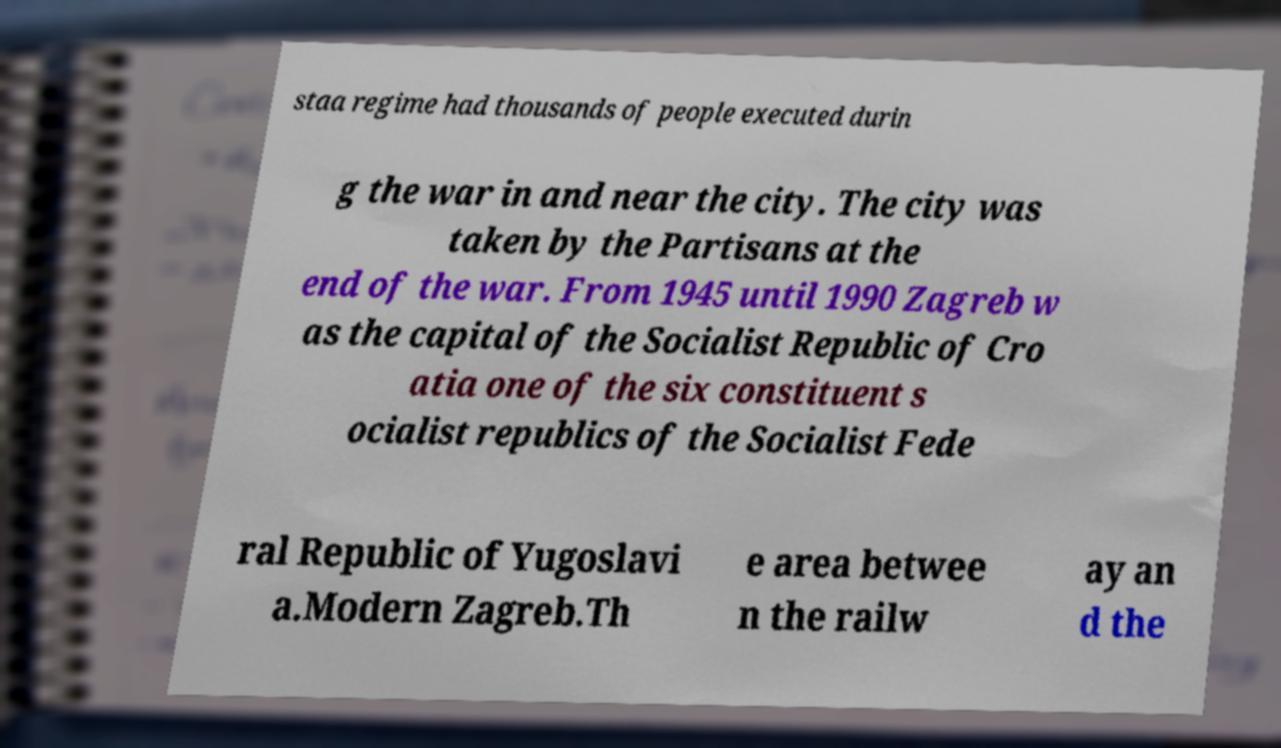I need the written content from this picture converted into text. Can you do that? staa regime had thousands of people executed durin g the war in and near the city. The city was taken by the Partisans at the end of the war. From 1945 until 1990 Zagreb w as the capital of the Socialist Republic of Cro atia one of the six constituent s ocialist republics of the Socialist Fede ral Republic of Yugoslavi a.Modern Zagreb.Th e area betwee n the railw ay an d the 